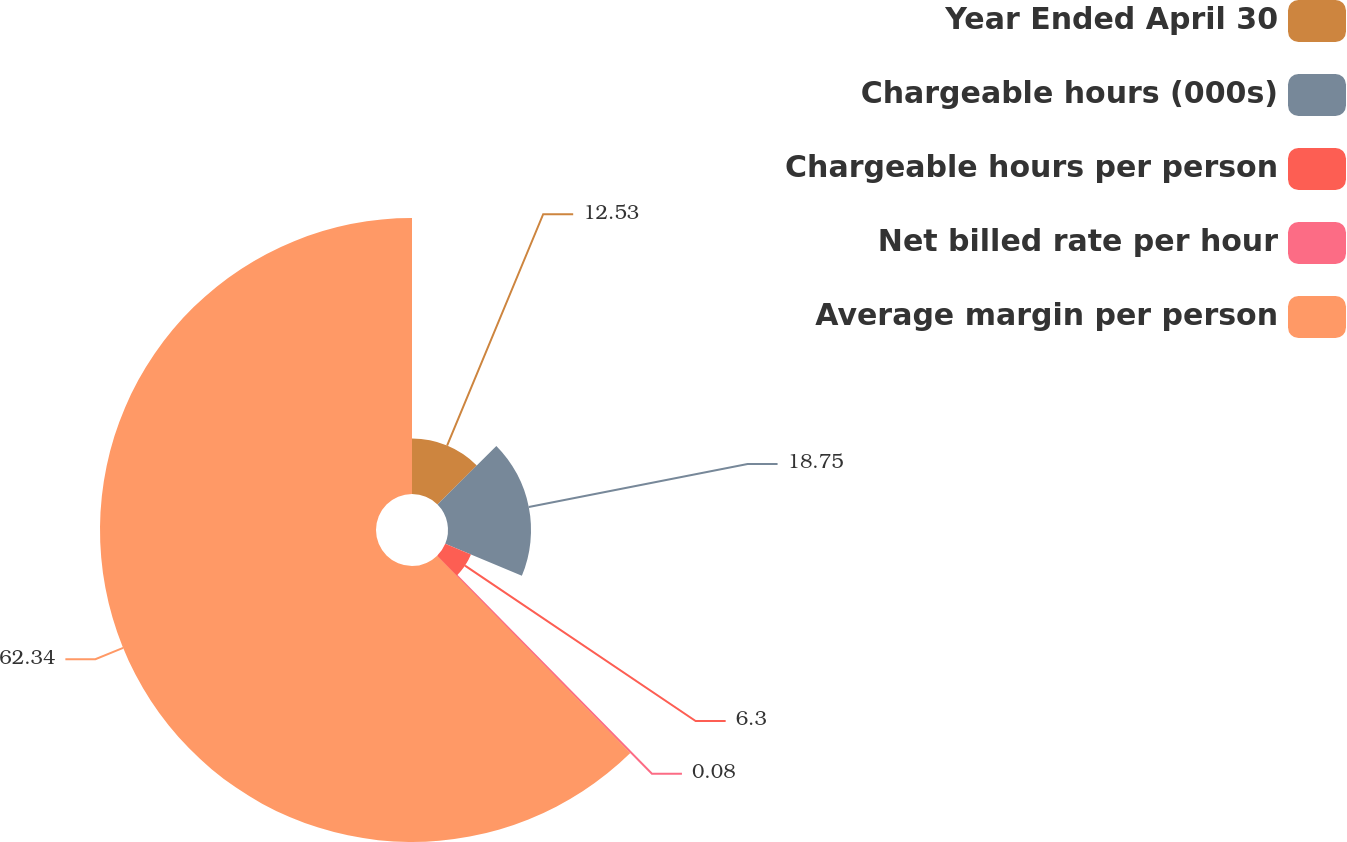<chart> <loc_0><loc_0><loc_500><loc_500><pie_chart><fcel>Year Ended April 30<fcel>Chargeable hours (000s)<fcel>Chargeable hours per person<fcel>Net billed rate per hour<fcel>Average margin per person<nl><fcel>12.53%<fcel>18.75%<fcel>6.3%<fcel>0.08%<fcel>62.33%<nl></chart> 